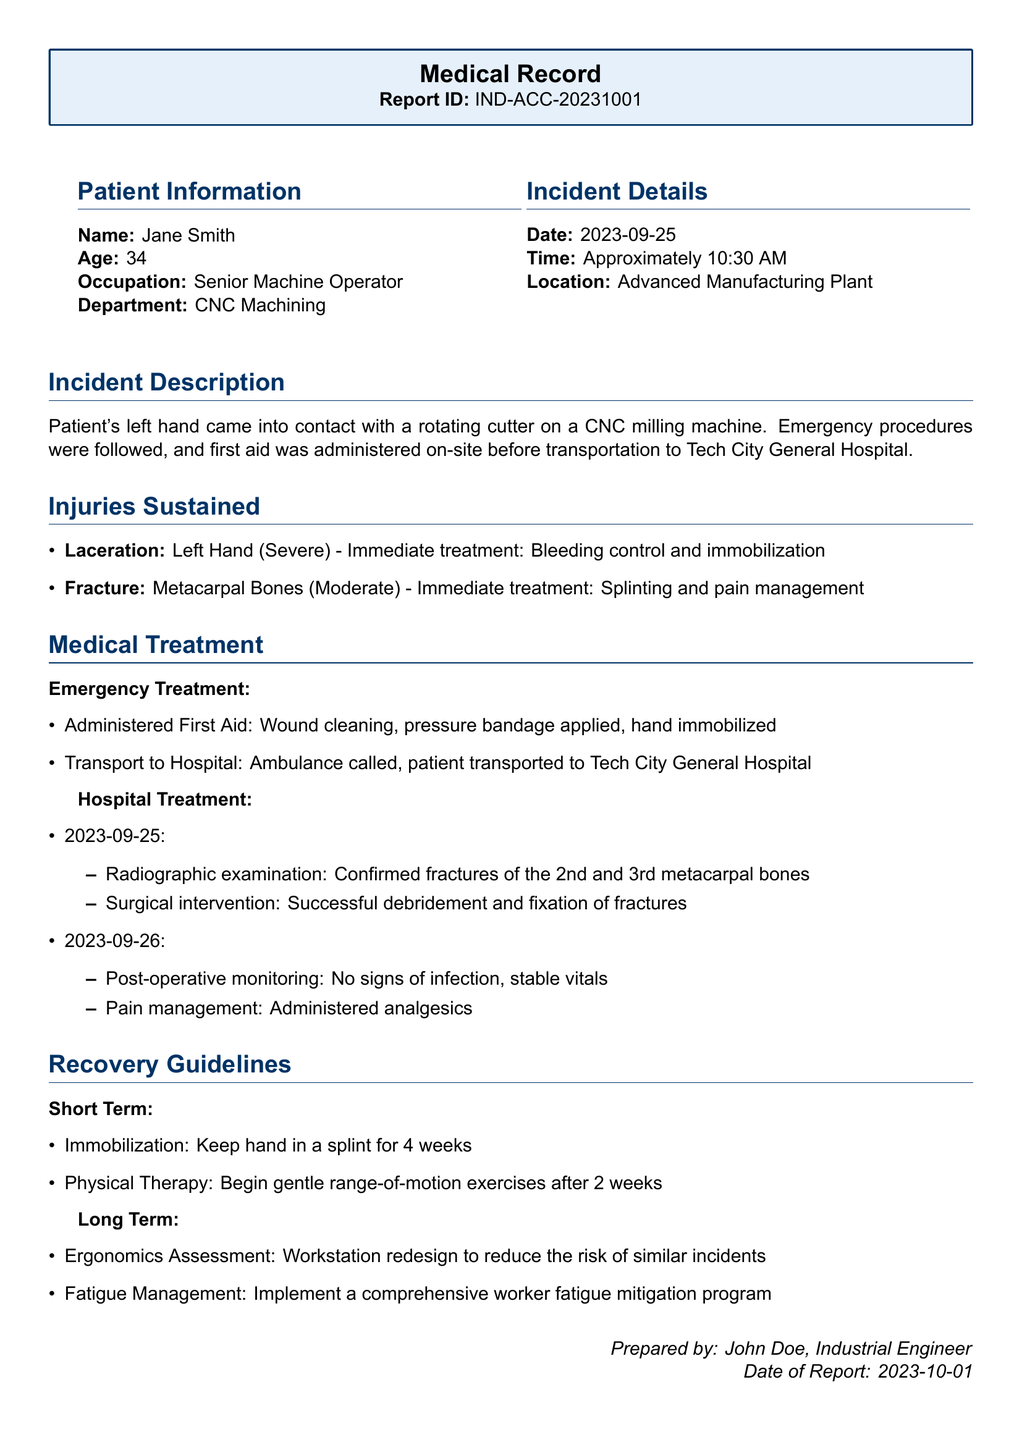What is the patient's name? The patient's name is clearly stated in the Patient Information section of the document.
Answer: Jane Smith What date did the incident occur? The incident date is found in the Incident Details section of the document.
Answer: 2023-09-25 What injury was sustained on the left hand? The type of injury on the left hand is listed under the Injuries Sustained section.
Answer: Laceration What type of surgical intervention was performed? The document mentions the surgical intervention under the Hospital Treatment section related to the patient's injuries.
Answer: Debridement and fixation How many weeks should the hand be immobilized? This information is found in the Recovery Guidelines under the Short Term care section.
Answer: 4 weeks What is the patient's occupation? The patient's occupation is mentioned in the Patient Information section.
Answer: Senior Machine Operator What was the location of the incident? The location of the incident is specified in the Incident Details section.
Answer: Advanced Manufacturing Plant What should be assessed for ergonomic improvement? This consideration is noted under the Long Term Recovery Guidelines.
Answer: Workstation redesign 